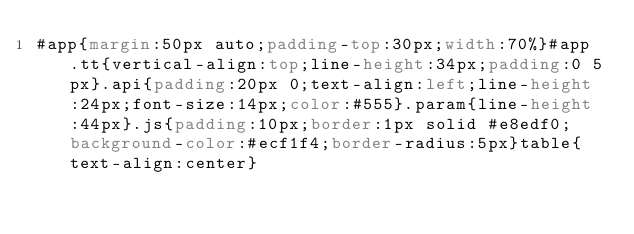<code> <loc_0><loc_0><loc_500><loc_500><_CSS_>#app{margin:50px auto;padding-top:30px;width:70%}#app .tt{vertical-align:top;line-height:34px;padding:0 5px}.api{padding:20px 0;text-align:left;line-height:24px;font-size:14px;color:#555}.param{line-height:44px}.js{padding:10px;border:1px solid #e8edf0;background-color:#ecf1f4;border-radius:5px}table{text-align:center}</code> 